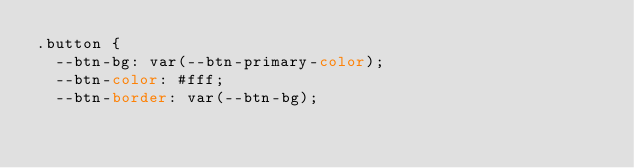Convert code to text. <code><loc_0><loc_0><loc_500><loc_500><_CSS_>.button {
  --btn-bg: var(--btn-primary-color);
  --btn-color: #fff;
  --btn-border: var(--btn-bg);</code> 